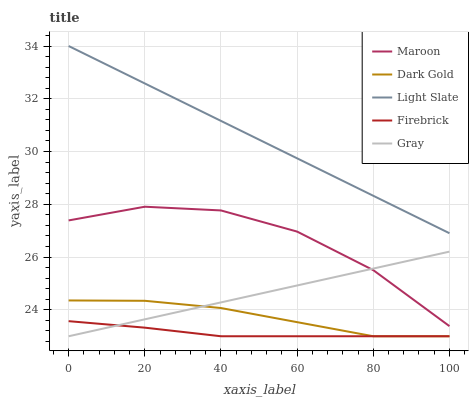Does Firebrick have the minimum area under the curve?
Answer yes or no. Yes. Does Light Slate have the maximum area under the curve?
Answer yes or no. Yes. Does Gray have the minimum area under the curve?
Answer yes or no. No. Does Gray have the maximum area under the curve?
Answer yes or no. No. Is Gray the smoothest?
Answer yes or no. Yes. Is Maroon the roughest?
Answer yes or no. Yes. Is Firebrick the smoothest?
Answer yes or no. No. Is Firebrick the roughest?
Answer yes or no. No. Does Gray have the lowest value?
Answer yes or no. Yes. Does Maroon have the lowest value?
Answer yes or no. No. Does Light Slate have the highest value?
Answer yes or no. Yes. Does Gray have the highest value?
Answer yes or no. No. Is Gray less than Light Slate?
Answer yes or no. Yes. Is Light Slate greater than Gray?
Answer yes or no. Yes. Does Maroon intersect Gray?
Answer yes or no. Yes. Is Maroon less than Gray?
Answer yes or no. No. Is Maroon greater than Gray?
Answer yes or no. No. Does Gray intersect Light Slate?
Answer yes or no. No. 